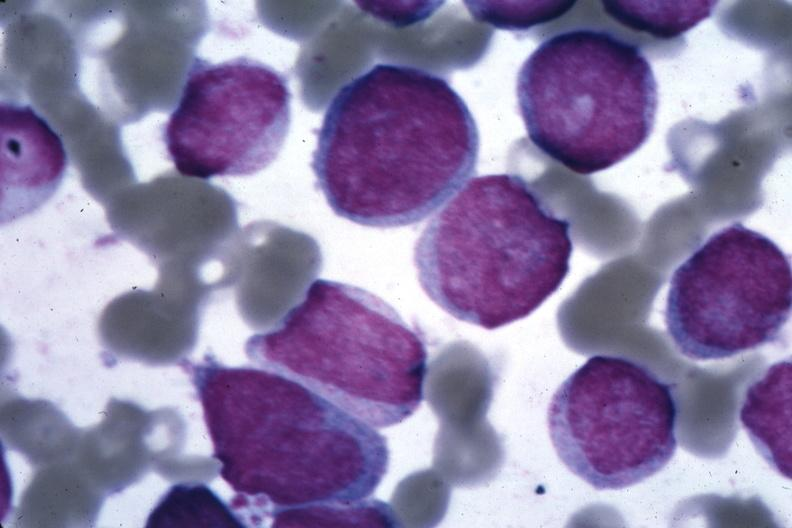what diagnosed?
Answer the question using a single word or phrase. Oil wrights cells 